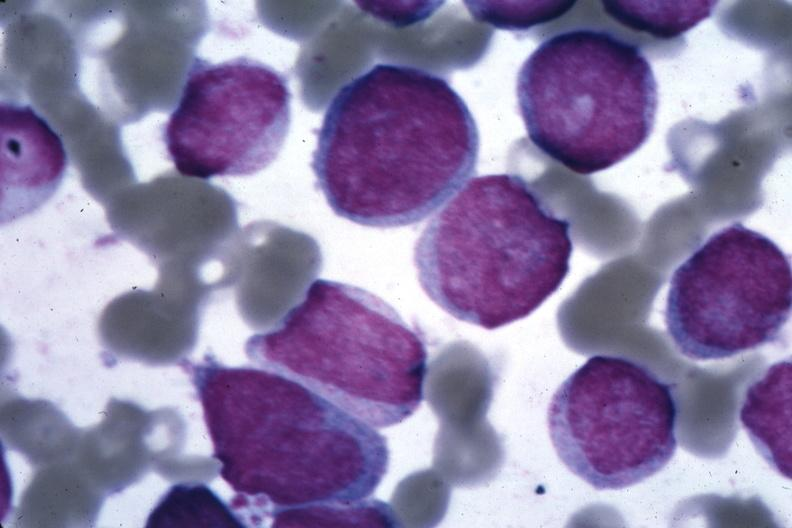what diagnosed?
Answer the question using a single word or phrase. Oil wrights cells 